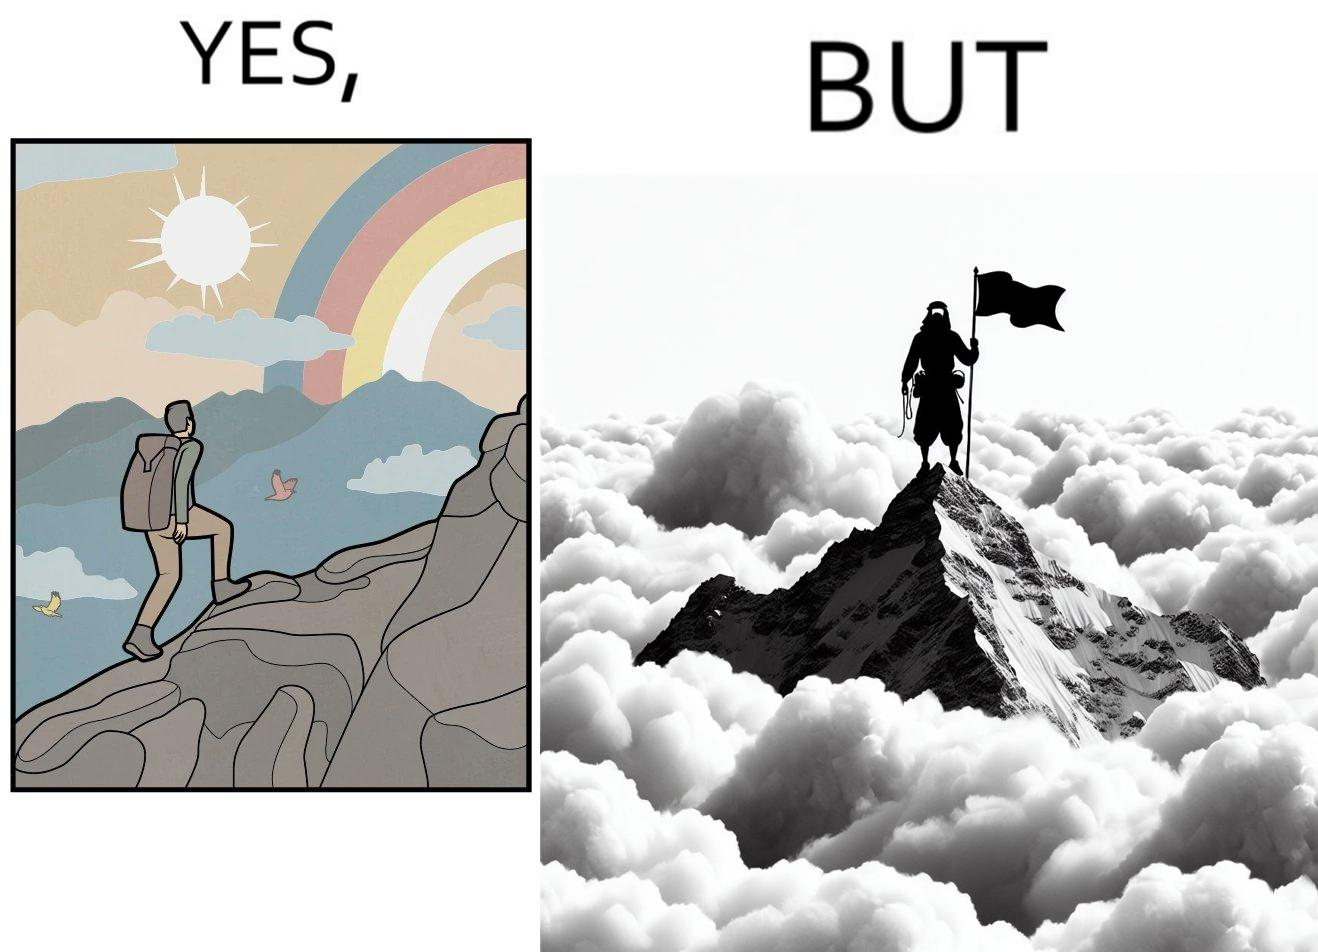Does this image contain satire or humor? Yes, this image is satirical. 